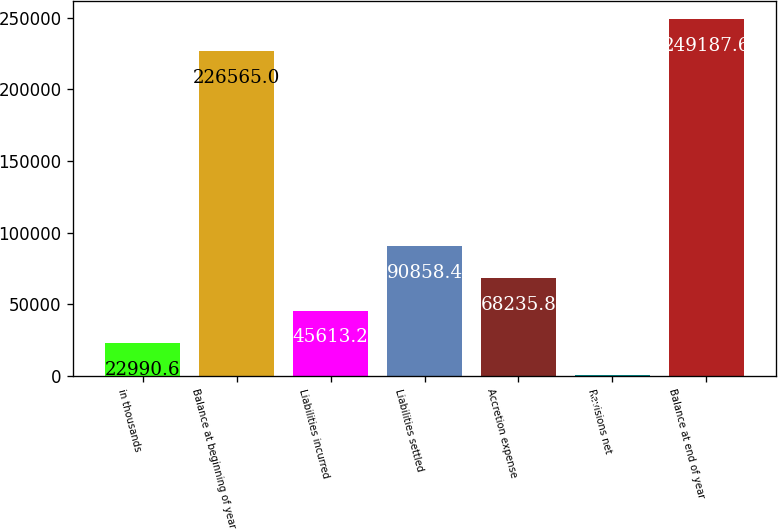Convert chart. <chart><loc_0><loc_0><loc_500><loc_500><bar_chart><fcel>in thousands<fcel>Balance at beginning of year<fcel>Liabilities incurred<fcel>Liabilities settled<fcel>Accretion expense<fcel>Revisions net<fcel>Balance at end of year<nl><fcel>22990.6<fcel>226565<fcel>45613.2<fcel>90858.4<fcel>68235.8<fcel>368<fcel>249188<nl></chart> 